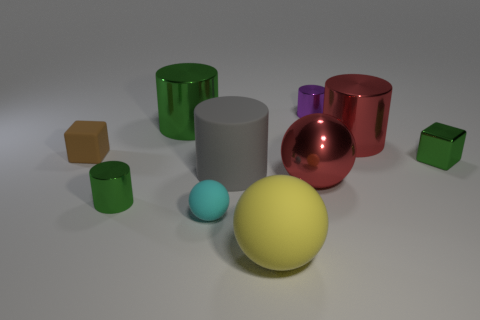Subtract all brown cylinders. Subtract all cyan blocks. How many cylinders are left? 5 Subtract all blocks. How many objects are left? 8 Subtract 0 cyan cubes. How many objects are left? 10 Subtract all yellow metal spheres. Subtract all small metallic cylinders. How many objects are left? 8 Add 5 big green objects. How many big green objects are left? 6 Add 2 tiny red shiny objects. How many tiny red shiny objects exist? 2 